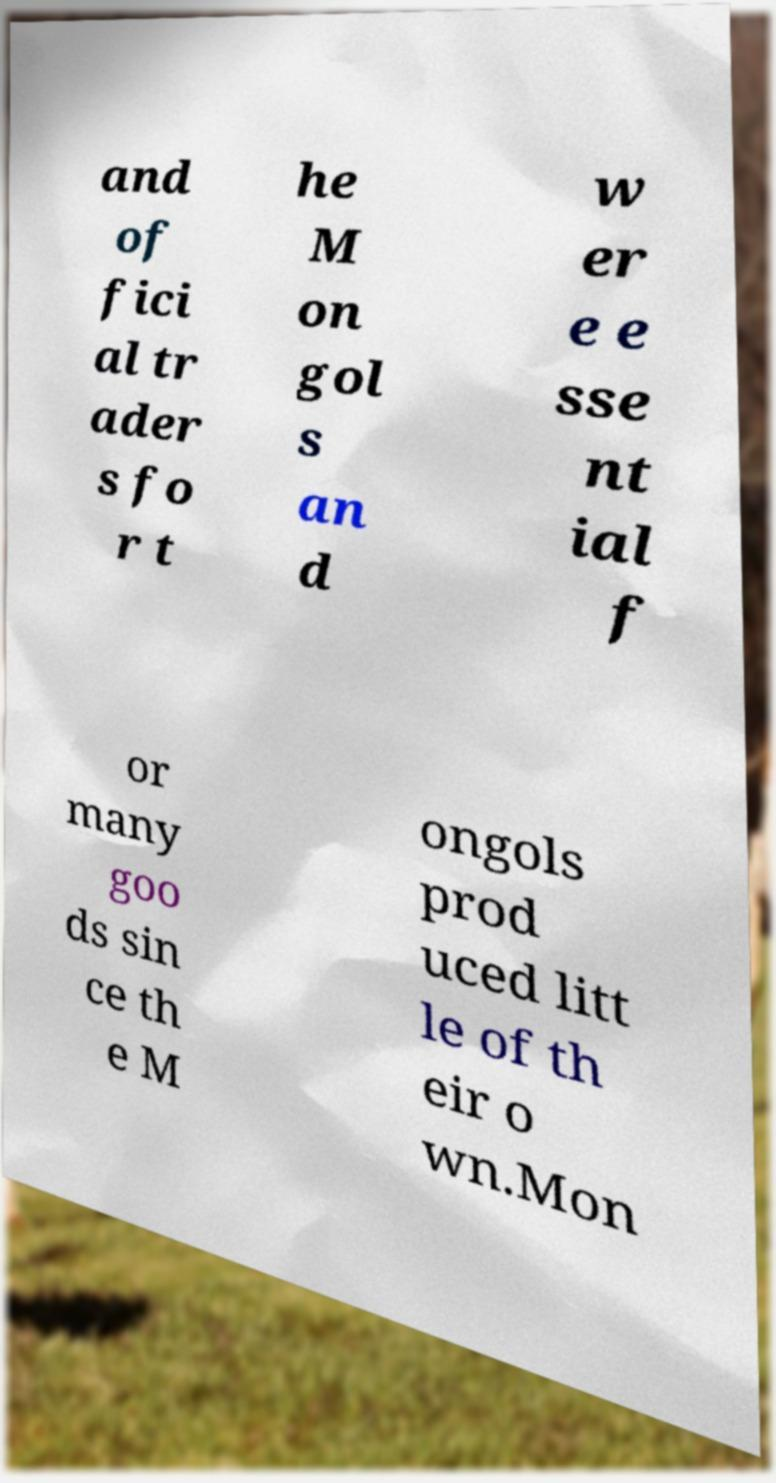There's text embedded in this image that I need extracted. Can you transcribe it verbatim? and of fici al tr ader s fo r t he M on gol s an d w er e e sse nt ial f or many goo ds sin ce th e M ongols prod uced litt le of th eir o wn.Mon 